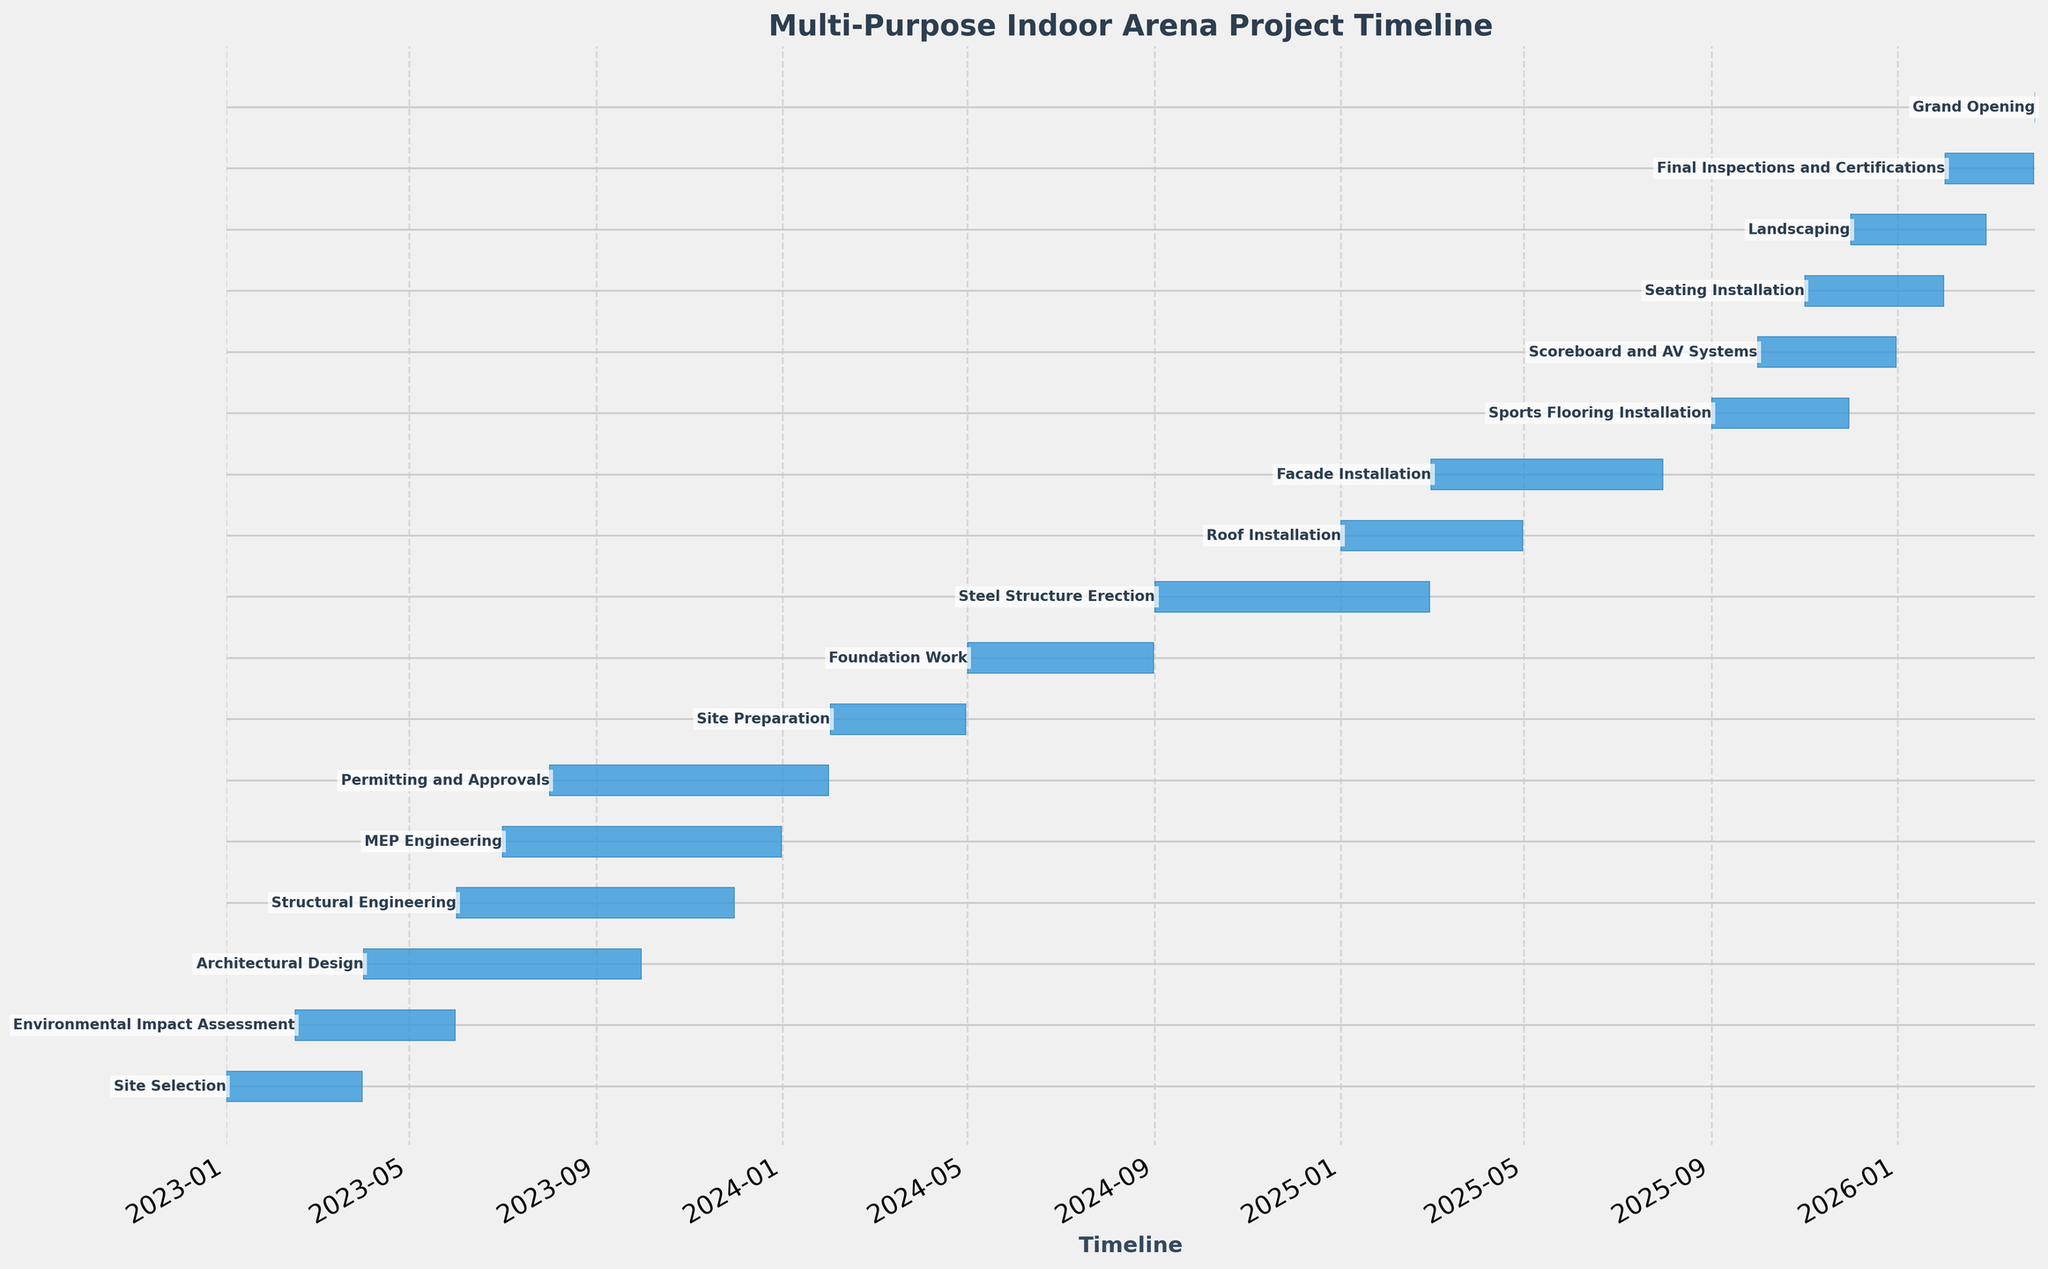what is the title of the chart? The chart's title is typically positioned at the top center of the figure to provide an overview of the content. In this case, the title is indicated at the top center of the Gantt chart.
Answer: Multi-Purpose Indoor Arena Project Timeline how is the x-axis labeled? The x-axis usually represents the time duration in Gantt charts. Here, the label "Timeline" can be found below the x-axis, indicating the period over which the tasks are distributed.
Answer: Timeline what task has the longest duration? To determine the task with the longest duration, look for the task bar that spans the largest interval between the start and end dates on the chart.
Answer: Architectural Design which two tasks are related to the architectural design task? Tasks related to Architectural Design can be identified by examining dependencies indicated by arrow labels or overlap. In this case, Structural Engineering and MEP Engineering have dependencies on Architectural Design as indicated by the [50%] dependencies.
Answer: Structural Engineering, MEP Engineering what is the time gap between the start of site preparation and foundation work? Site Preparation starts on 2024-02-01 and ends on 2024-04-30. Foundation Work starts on 2024-05-01. The gap between the end of Site Preparation and the start of Foundation Work is 1 day (2024-05-01 minus 2024-04-30).
Answer: 1 day which task immediately precedes the grand opening? Identify the task that ends just before the Grand Opening. According to the dependencies, Final Inspections and Certifications come right before the Grand Opening.
Answer: Final Inspections and Certifications during which months does the roof installation start and end? Roof Installation starts on 2025-01-01 and ends on 2025-04-30, covering the months of January to April 2025.
Answer: January to April 2025 how many tasks depend on the structural engineering task? Count the number of tasks that have dependencies indicated by Structural Engineering. Here, no tasks explicitly depend on Structural Engineering.
Answer: None how is the façade installation task related to the steel structure erection task? Façade Installation depends on the Steel Structure Erection at 75% completion as indicated by the position of arrows on the chart.
Answer: Steel Structure Erection[75%] what's the time duration for the landscaping task? Locate the start and end dates for Landscaping: it begins on 2025-12-01 and ends on 2026-02-28. The duration calculation involves counting the days between these dates, totaling 90 days.
Answer: 90 days 